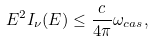<formula> <loc_0><loc_0><loc_500><loc_500>E ^ { 2 } I _ { \nu } ( E ) \leq \frac { c } { 4 \pi } \omega _ { c a s } ,</formula> 